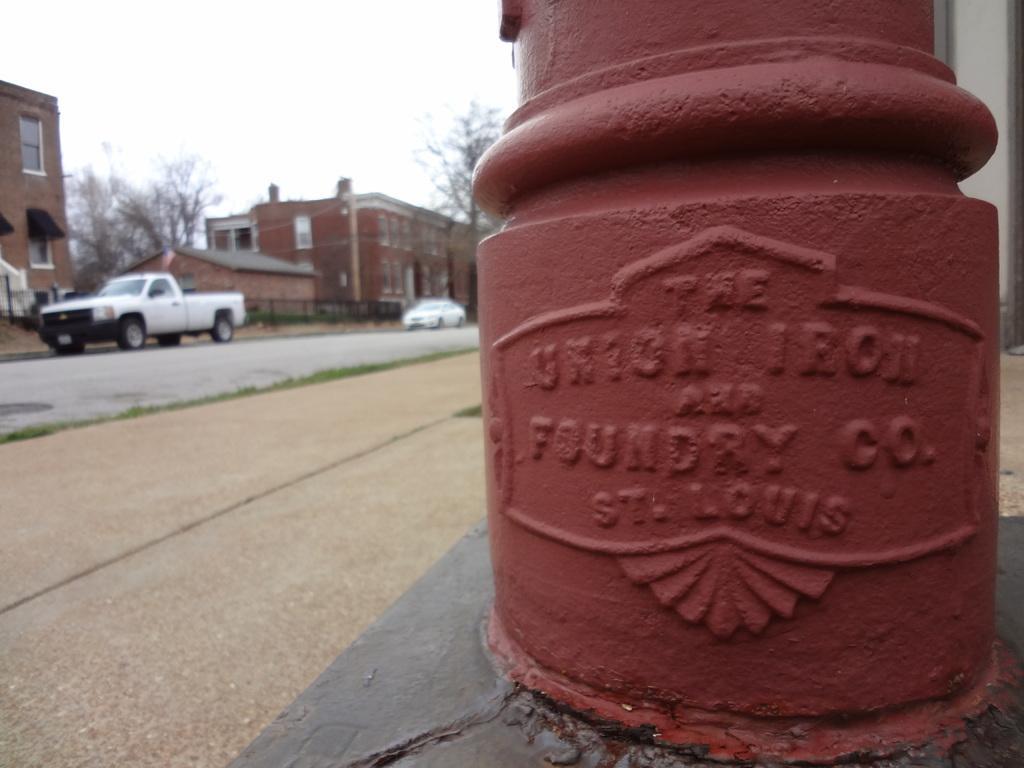Please provide a concise description of this image. In the center of the image we can see one pole, which is a brown color. And we can see some text on the pole. And we can see a few vehicles on the road. In the background we can see the sky, clouds, trees, buildings etc. 